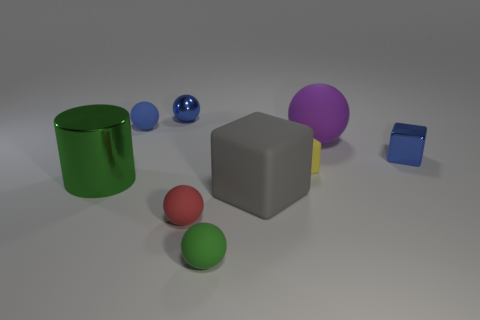How many big objects are there?
Provide a short and direct response. 3. There is a large object that is both on the right side of the large shiny cylinder and in front of the tiny yellow block; what is its shape?
Offer a very short reply. Cube. Does the matte object that is to the left of the blue metallic ball have the same color as the small metallic object to the right of the green rubber ball?
Provide a short and direct response. Yes. Is there a large sphere made of the same material as the yellow thing?
Provide a succinct answer. Yes. Are there an equal number of green rubber balls behind the red rubber thing and tiny blue metallic things that are on the right side of the small yellow matte block?
Your response must be concise. No. There is a green thing behind the big gray matte thing; what size is it?
Give a very brief answer. Large. What is the material of the small blue ball to the right of the rubber thing on the left side of the tiny red thing?
Your response must be concise. Metal. There is a large green object that is in front of the sphere that is to the right of the big gray block; what number of small blue shiny cubes are in front of it?
Make the answer very short. 0. Is the material of the small cube behind the tiny yellow object the same as the green object that is to the right of the blue rubber ball?
Ensure brevity in your answer.  No. What material is the block that is the same color as the metal ball?
Offer a terse response. Metal. 